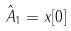<formula> <loc_0><loc_0><loc_500><loc_500>\hat { A } _ { 1 } = x [ 0 ]</formula> 